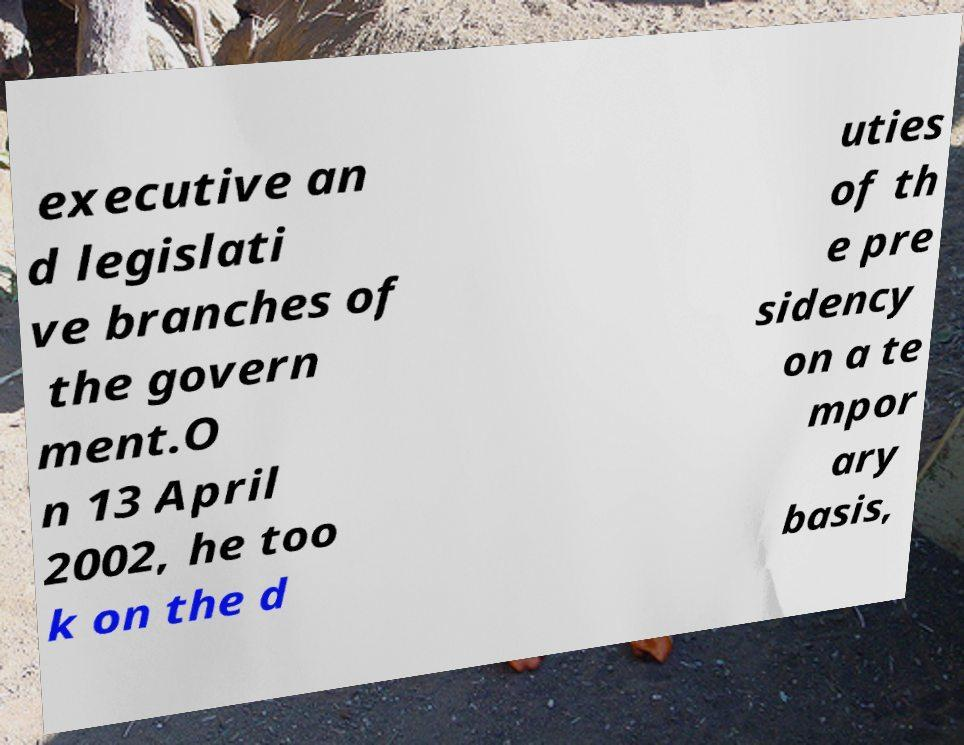Please read and relay the text visible in this image. What does it say? executive an d legislati ve branches of the govern ment.O n 13 April 2002, he too k on the d uties of th e pre sidency on a te mpor ary basis, 